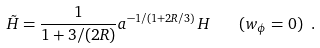Convert formula to latex. <formula><loc_0><loc_0><loc_500><loc_500>\tilde { H } = \frac { 1 } { 1 + 3 / ( 2 R ) } a ^ { - 1 / ( 1 + 2 R / 3 ) } \, H \quad ( w _ { \phi } = 0 ) \ .</formula> 